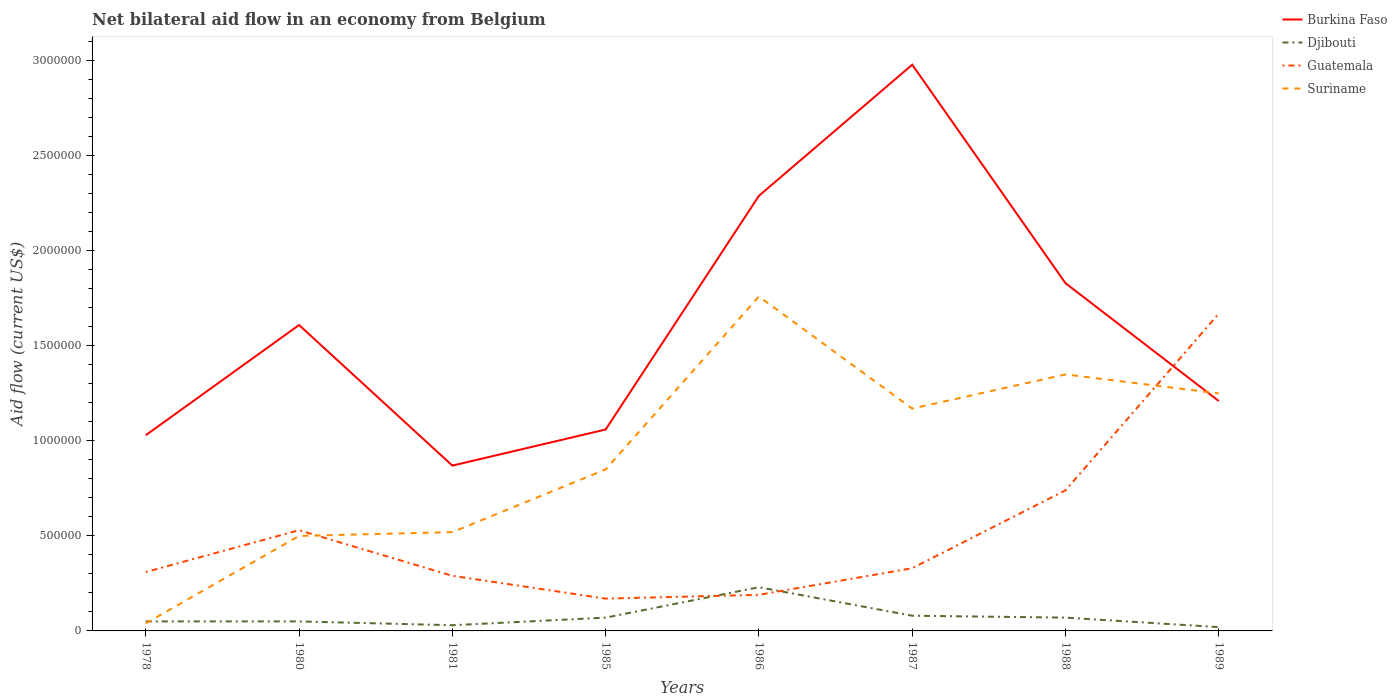Does the line corresponding to Burkina Faso intersect with the line corresponding to Djibouti?
Your response must be concise. No. Is the number of lines equal to the number of legend labels?
Make the answer very short. Yes. Across all years, what is the maximum net bilateral aid flow in Suriname?
Ensure brevity in your answer.  4.00e+04. What is the total net bilateral aid flow in Guatemala in the graph?
Give a very brief answer. -1.38e+06. What is the difference between the highest and the second highest net bilateral aid flow in Djibouti?
Offer a very short reply. 2.10e+05. What is the difference between the highest and the lowest net bilateral aid flow in Suriname?
Give a very brief answer. 4. Is the net bilateral aid flow in Burkina Faso strictly greater than the net bilateral aid flow in Djibouti over the years?
Your response must be concise. No. How many years are there in the graph?
Offer a very short reply. 8. Does the graph contain any zero values?
Give a very brief answer. No. Does the graph contain grids?
Provide a succinct answer. No. Where does the legend appear in the graph?
Keep it short and to the point. Top right. What is the title of the graph?
Your answer should be very brief. Net bilateral aid flow in an economy from Belgium. Does "Panama" appear as one of the legend labels in the graph?
Provide a succinct answer. No. What is the Aid flow (current US$) of Burkina Faso in 1978?
Offer a terse response. 1.03e+06. What is the Aid flow (current US$) of Djibouti in 1978?
Give a very brief answer. 5.00e+04. What is the Aid flow (current US$) in Guatemala in 1978?
Your response must be concise. 3.10e+05. What is the Aid flow (current US$) in Burkina Faso in 1980?
Keep it short and to the point. 1.61e+06. What is the Aid flow (current US$) of Guatemala in 1980?
Give a very brief answer. 5.30e+05. What is the Aid flow (current US$) of Suriname in 1980?
Make the answer very short. 5.00e+05. What is the Aid flow (current US$) in Burkina Faso in 1981?
Offer a terse response. 8.70e+05. What is the Aid flow (current US$) of Djibouti in 1981?
Ensure brevity in your answer.  3.00e+04. What is the Aid flow (current US$) in Guatemala in 1981?
Your response must be concise. 2.90e+05. What is the Aid flow (current US$) in Suriname in 1981?
Offer a terse response. 5.20e+05. What is the Aid flow (current US$) of Burkina Faso in 1985?
Ensure brevity in your answer.  1.06e+06. What is the Aid flow (current US$) of Suriname in 1985?
Your response must be concise. 8.50e+05. What is the Aid flow (current US$) in Burkina Faso in 1986?
Your answer should be very brief. 2.29e+06. What is the Aid flow (current US$) of Djibouti in 1986?
Your answer should be compact. 2.30e+05. What is the Aid flow (current US$) in Suriname in 1986?
Your answer should be very brief. 1.76e+06. What is the Aid flow (current US$) in Burkina Faso in 1987?
Your response must be concise. 2.98e+06. What is the Aid flow (current US$) in Suriname in 1987?
Ensure brevity in your answer.  1.17e+06. What is the Aid flow (current US$) of Burkina Faso in 1988?
Offer a terse response. 1.83e+06. What is the Aid flow (current US$) of Djibouti in 1988?
Your answer should be compact. 7.00e+04. What is the Aid flow (current US$) in Guatemala in 1988?
Ensure brevity in your answer.  7.40e+05. What is the Aid flow (current US$) of Suriname in 1988?
Your answer should be compact. 1.35e+06. What is the Aid flow (current US$) of Burkina Faso in 1989?
Your answer should be very brief. 1.21e+06. What is the Aid flow (current US$) of Djibouti in 1989?
Ensure brevity in your answer.  2.00e+04. What is the Aid flow (current US$) of Guatemala in 1989?
Your answer should be very brief. 1.67e+06. What is the Aid flow (current US$) of Suriname in 1989?
Provide a succinct answer. 1.25e+06. Across all years, what is the maximum Aid flow (current US$) of Burkina Faso?
Your answer should be compact. 2.98e+06. Across all years, what is the maximum Aid flow (current US$) of Guatemala?
Keep it short and to the point. 1.67e+06. Across all years, what is the maximum Aid flow (current US$) in Suriname?
Offer a terse response. 1.76e+06. Across all years, what is the minimum Aid flow (current US$) of Burkina Faso?
Offer a terse response. 8.70e+05. Across all years, what is the minimum Aid flow (current US$) in Guatemala?
Ensure brevity in your answer.  1.70e+05. Across all years, what is the minimum Aid flow (current US$) in Suriname?
Your answer should be very brief. 4.00e+04. What is the total Aid flow (current US$) in Burkina Faso in the graph?
Offer a terse response. 1.29e+07. What is the total Aid flow (current US$) in Guatemala in the graph?
Provide a succinct answer. 4.23e+06. What is the total Aid flow (current US$) in Suriname in the graph?
Offer a very short reply. 7.44e+06. What is the difference between the Aid flow (current US$) in Burkina Faso in 1978 and that in 1980?
Give a very brief answer. -5.80e+05. What is the difference between the Aid flow (current US$) of Guatemala in 1978 and that in 1980?
Provide a short and direct response. -2.20e+05. What is the difference between the Aid flow (current US$) of Suriname in 1978 and that in 1980?
Give a very brief answer. -4.60e+05. What is the difference between the Aid flow (current US$) of Burkina Faso in 1978 and that in 1981?
Give a very brief answer. 1.60e+05. What is the difference between the Aid flow (current US$) of Guatemala in 1978 and that in 1981?
Provide a succinct answer. 2.00e+04. What is the difference between the Aid flow (current US$) of Suriname in 1978 and that in 1981?
Your answer should be compact. -4.80e+05. What is the difference between the Aid flow (current US$) of Burkina Faso in 1978 and that in 1985?
Your answer should be compact. -3.00e+04. What is the difference between the Aid flow (current US$) in Guatemala in 1978 and that in 1985?
Offer a very short reply. 1.40e+05. What is the difference between the Aid flow (current US$) in Suriname in 1978 and that in 1985?
Your answer should be very brief. -8.10e+05. What is the difference between the Aid flow (current US$) in Burkina Faso in 1978 and that in 1986?
Keep it short and to the point. -1.26e+06. What is the difference between the Aid flow (current US$) in Djibouti in 1978 and that in 1986?
Provide a succinct answer. -1.80e+05. What is the difference between the Aid flow (current US$) in Guatemala in 1978 and that in 1986?
Offer a terse response. 1.20e+05. What is the difference between the Aid flow (current US$) of Suriname in 1978 and that in 1986?
Your answer should be very brief. -1.72e+06. What is the difference between the Aid flow (current US$) in Burkina Faso in 1978 and that in 1987?
Provide a succinct answer. -1.95e+06. What is the difference between the Aid flow (current US$) of Suriname in 1978 and that in 1987?
Your answer should be very brief. -1.13e+06. What is the difference between the Aid flow (current US$) of Burkina Faso in 1978 and that in 1988?
Offer a terse response. -8.00e+05. What is the difference between the Aid flow (current US$) of Djibouti in 1978 and that in 1988?
Make the answer very short. -2.00e+04. What is the difference between the Aid flow (current US$) in Guatemala in 1978 and that in 1988?
Keep it short and to the point. -4.30e+05. What is the difference between the Aid flow (current US$) of Suriname in 1978 and that in 1988?
Provide a short and direct response. -1.31e+06. What is the difference between the Aid flow (current US$) of Burkina Faso in 1978 and that in 1989?
Your response must be concise. -1.80e+05. What is the difference between the Aid flow (current US$) of Djibouti in 1978 and that in 1989?
Provide a succinct answer. 3.00e+04. What is the difference between the Aid flow (current US$) in Guatemala in 1978 and that in 1989?
Make the answer very short. -1.36e+06. What is the difference between the Aid flow (current US$) in Suriname in 1978 and that in 1989?
Keep it short and to the point. -1.21e+06. What is the difference between the Aid flow (current US$) of Burkina Faso in 1980 and that in 1981?
Make the answer very short. 7.40e+05. What is the difference between the Aid flow (current US$) of Djibouti in 1980 and that in 1981?
Ensure brevity in your answer.  2.00e+04. What is the difference between the Aid flow (current US$) of Suriname in 1980 and that in 1981?
Keep it short and to the point. -2.00e+04. What is the difference between the Aid flow (current US$) in Burkina Faso in 1980 and that in 1985?
Your response must be concise. 5.50e+05. What is the difference between the Aid flow (current US$) in Guatemala in 1980 and that in 1985?
Your answer should be very brief. 3.60e+05. What is the difference between the Aid flow (current US$) in Suriname in 1980 and that in 1985?
Provide a succinct answer. -3.50e+05. What is the difference between the Aid flow (current US$) of Burkina Faso in 1980 and that in 1986?
Give a very brief answer. -6.80e+05. What is the difference between the Aid flow (current US$) in Guatemala in 1980 and that in 1986?
Ensure brevity in your answer.  3.40e+05. What is the difference between the Aid flow (current US$) of Suriname in 1980 and that in 1986?
Your answer should be compact. -1.26e+06. What is the difference between the Aid flow (current US$) in Burkina Faso in 1980 and that in 1987?
Your response must be concise. -1.37e+06. What is the difference between the Aid flow (current US$) of Djibouti in 1980 and that in 1987?
Give a very brief answer. -3.00e+04. What is the difference between the Aid flow (current US$) of Suriname in 1980 and that in 1987?
Provide a succinct answer. -6.70e+05. What is the difference between the Aid flow (current US$) in Djibouti in 1980 and that in 1988?
Provide a short and direct response. -2.00e+04. What is the difference between the Aid flow (current US$) of Guatemala in 1980 and that in 1988?
Provide a succinct answer. -2.10e+05. What is the difference between the Aid flow (current US$) of Suriname in 1980 and that in 1988?
Your answer should be compact. -8.50e+05. What is the difference between the Aid flow (current US$) of Burkina Faso in 1980 and that in 1989?
Ensure brevity in your answer.  4.00e+05. What is the difference between the Aid flow (current US$) in Djibouti in 1980 and that in 1989?
Provide a succinct answer. 3.00e+04. What is the difference between the Aid flow (current US$) in Guatemala in 1980 and that in 1989?
Make the answer very short. -1.14e+06. What is the difference between the Aid flow (current US$) in Suriname in 1980 and that in 1989?
Your answer should be compact. -7.50e+05. What is the difference between the Aid flow (current US$) of Guatemala in 1981 and that in 1985?
Ensure brevity in your answer.  1.20e+05. What is the difference between the Aid flow (current US$) in Suriname in 1981 and that in 1985?
Offer a terse response. -3.30e+05. What is the difference between the Aid flow (current US$) in Burkina Faso in 1981 and that in 1986?
Ensure brevity in your answer.  -1.42e+06. What is the difference between the Aid flow (current US$) in Djibouti in 1981 and that in 1986?
Offer a very short reply. -2.00e+05. What is the difference between the Aid flow (current US$) in Guatemala in 1981 and that in 1986?
Your answer should be compact. 1.00e+05. What is the difference between the Aid flow (current US$) of Suriname in 1981 and that in 1986?
Your answer should be very brief. -1.24e+06. What is the difference between the Aid flow (current US$) in Burkina Faso in 1981 and that in 1987?
Offer a very short reply. -2.11e+06. What is the difference between the Aid flow (current US$) in Guatemala in 1981 and that in 1987?
Ensure brevity in your answer.  -4.00e+04. What is the difference between the Aid flow (current US$) of Suriname in 1981 and that in 1987?
Make the answer very short. -6.50e+05. What is the difference between the Aid flow (current US$) in Burkina Faso in 1981 and that in 1988?
Provide a succinct answer. -9.60e+05. What is the difference between the Aid flow (current US$) in Guatemala in 1981 and that in 1988?
Make the answer very short. -4.50e+05. What is the difference between the Aid flow (current US$) of Suriname in 1981 and that in 1988?
Ensure brevity in your answer.  -8.30e+05. What is the difference between the Aid flow (current US$) of Djibouti in 1981 and that in 1989?
Provide a succinct answer. 10000. What is the difference between the Aid flow (current US$) of Guatemala in 1981 and that in 1989?
Offer a terse response. -1.38e+06. What is the difference between the Aid flow (current US$) in Suriname in 1981 and that in 1989?
Your response must be concise. -7.30e+05. What is the difference between the Aid flow (current US$) in Burkina Faso in 1985 and that in 1986?
Make the answer very short. -1.23e+06. What is the difference between the Aid flow (current US$) of Suriname in 1985 and that in 1986?
Keep it short and to the point. -9.10e+05. What is the difference between the Aid flow (current US$) in Burkina Faso in 1985 and that in 1987?
Provide a succinct answer. -1.92e+06. What is the difference between the Aid flow (current US$) in Guatemala in 1985 and that in 1987?
Your answer should be compact. -1.60e+05. What is the difference between the Aid flow (current US$) in Suriname in 1985 and that in 1987?
Offer a very short reply. -3.20e+05. What is the difference between the Aid flow (current US$) in Burkina Faso in 1985 and that in 1988?
Keep it short and to the point. -7.70e+05. What is the difference between the Aid flow (current US$) of Guatemala in 1985 and that in 1988?
Ensure brevity in your answer.  -5.70e+05. What is the difference between the Aid flow (current US$) in Suriname in 1985 and that in 1988?
Ensure brevity in your answer.  -5.00e+05. What is the difference between the Aid flow (current US$) in Guatemala in 1985 and that in 1989?
Offer a very short reply. -1.50e+06. What is the difference between the Aid flow (current US$) in Suriname in 1985 and that in 1989?
Your response must be concise. -4.00e+05. What is the difference between the Aid flow (current US$) of Burkina Faso in 1986 and that in 1987?
Make the answer very short. -6.90e+05. What is the difference between the Aid flow (current US$) in Suriname in 1986 and that in 1987?
Provide a succinct answer. 5.90e+05. What is the difference between the Aid flow (current US$) of Burkina Faso in 1986 and that in 1988?
Offer a very short reply. 4.60e+05. What is the difference between the Aid flow (current US$) of Guatemala in 1986 and that in 1988?
Your answer should be compact. -5.50e+05. What is the difference between the Aid flow (current US$) of Suriname in 1986 and that in 1988?
Offer a terse response. 4.10e+05. What is the difference between the Aid flow (current US$) of Burkina Faso in 1986 and that in 1989?
Your answer should be very brief. 1.08e+06. What is the difference between the Aid flow (current US$) in Djibouti in 1986 and that in 1989?
Your response must be concise. 2.10e+05. What is the difference between the Aid flow (current US$) in Guatemala in 1986 and that in 1989?
Your response must be concise. -1.48e+06. What is the difference between the Aid flow (current US$) of Suriname in 1986 and that in 1989?
Your response must be concise. 5.10e+05. What is the difference between the Aid flow (current US$) of Burkina Faso in 1987 and that in 1988?
Offer a terse response. 1.15e+06. What is the difference between the Aid flow (current US$) in Guatemala in 1987 and that in 1988?
Offer a terse response. -4.10e+05. What is the difference between the Aid flow (current US$) of Burkina Faso in 1987 and that in 1989?
Your answer should be compact. 1.77e+06. What is the difference between the Aid flow (current US$) of Guatemala in 1987 and that in 1989?
Keep it short and to the point. -1.34e+06. What is the difference between the Aid flow (current US$) in Burkina Faso in 1988 and that in 1989?
Your response must be concise. 6.20e+05. What is the difference between the Aid flow (current US$) in Djibouti in 1988 and that in 1989?
Offer a very short reply. 5.00e+04. What is the difference between the Aid flow (current US$) in Guatemala in 1988 and that in 1989?
Your answer should be compact. -9.30e+05. What is the difference between the Aid flow (current US$) in Suriname in 1988 and that in 1989?
Offer a very short reply. 1.00e+05. What is the difference between the Aid flow (current US$) in Burkina Faso in 1978 and the Aid flow (current US$) in Djibouti in 1980?
Keep it short and to the point. 9.80e+05. What is the difference between the Aid flow (current US$) of Burkina Faso in 1978 and the Aid flow (current US$) of Suriname in 1980?
Ensure brevity in your answer.  5.30e+05. What is the difference between the Aid flow (current US$) in Djibouti in 1978 and the Aid flow (current US$) in Guatemala in 1980?
Your answer should be very brief. -4.80e+05. What is the difference between the Aid flow (current US$) in Djibouti in 1978 and the Aid flow (current US$) in Suriname in 1980?
Provide a succinct answer. -4.50e+05. What is the difference between the Aid flow (current US$) of Guatemala in 1978 and the Aid flow (current US$) of Suriname in 1980?
Provide a short and direct response. -1.90e+05. What is the difference between the Aid flow (current US$) in Burkina Faso in 1978 and the Aid flow (current US$) in Djibouti in 1981?
Offer a terse response. 1.00e+06. What is the difference between the Aid flow (current US$) of Burkina Faso in 1978 and the Aid flow (current US$) of Guatemala in 1981?
Give a very brief answer. 7.40e+05. What is the difference between the Aid flow (current US$) of Burkina Faso in 1978 and the Aid flow (current US$) of Suriname in 1981?
Offer a terse response. 5.10e+05. What is the difference between the Aid flow (current US$) in Djibouti in 1978 and the Aid flow (current US$) in Suriname in 1981?
Offer a terse response. -4.70e+05. What is the difference between the Aid flow (current US$) of Burkina Faso in 1978 and the Aid flow (current US$) of Djibouti in 1985?
Ensure brevity in your answer.  9.60e+05. What is the difference between the Aid flow (current US$) in Burkina Faso in 1978 and the Aid flow (current US$) in Guatemala in 1985?
Make the answer very short. 8.60e+05. What is the difference between the Aid flow (current US$) in Djibouti in 1978 and the Aid flow (current US$) in Guatemala in 1985?
Give a very brief answer. -1.20e+05. What is the difference between the Aid flow (current US$) of Djibouti in 1978 and the Aid flow (current US$) of Suriname in 1985?
Keep it short and to the point. -8.00e+05. What is the difference between the Aid flow (current US$) in Guatemala in 1978 and the Aid flow (current US$) in Suriname in 1985?
Your answer should be compact. -5.40e+05. What is the difference between the Aid flow (current US$) of Burkina Faso in 1978 and the Aid flow (current US$) of Djibouti in 1986?
Keep it short and to the point. 8.00e+05. What is the difference between the Aid flow (current US$) of Burkina Faso in 1978 and the Aid flow (current US$) of Guatemala in 1986?
Your answer should be compact. 8.40e+05. What is the difference between the Aid flow (current US$) of Burkina Faso in 1978 and the Aid flow (current US$) of Suriname in 1986?
Give a very brief answer. -7.30e+05. What is the difference between the Aid flow (current US$) of Djibouti in 1978 and the Aid flow (current US$) of Suriname in 1986?
Make the answer very short. -1.71e+06. What is the difference between the Aid flow (current US$) in Guatemala in 1978 and the Aid flow (current US$) in Suriname in 1986?
Keep it short and to the point. -1.45e+06. What is the difference between the Aid flow (current US$) in Burkina Faso in 1978 and the Aid flow (current US$) in Djibouti in 1987?
Offer a very short reply. 9.50e+05. What is the difference between the Aid flow (current US$) in Burkina Faso in 1978 and the Aid flow (current US$) in Suriname in 1987?
Your answer should be very brief. -1.40e+05. What is the difference between the Aid flow (current US$) in Djibouti in 1978 and the Aid flow (current US$) in Guatemala in 1987?
Your response must be concise. -2.80e+05. What is the difference between the Aid flow (current US$) in Djibouti in 1978 and the Aid flow (current US$) in Suriname in 1987?
Provide a short and direct response. -1.12e+06. What is the difference between the Aid flow (current US$) in Guatemala in 1978 and the Aid flow (current US$) in Suriname in 1987?
Keep it short and to the point. -8.60e+05. What is the difference between the Aid flow (current US$) in Burkina Faso in 1978 and the Aid flow (current US$) in Djibouti in 1988?
Provide a short and direct response. 9.60e+05. What is the difference between the Aid flow (current US$) of Burkina Faso in 1978 and the Aid flow (current US$) of Suriname in 1988?
Offer a terse response. -3.20e+05. What is the difference between the Aid flow (current US$) of Djibouti in 1978 and the Aid flow (current US$) of Guatemala in 1988?
Ensure brevity in your answer.  -6.90e+05. What is the difference between the Aid flow (current US$) of Djibouti in 1978 and the Aid flow (current US$) of Suriname in 1988?
Offer a terse response. -1.30e+06. What is the difference between the Aid flow (current US$) of Guatemala in 1978 and the Aid flow (current US$) of Suriname in 1988?
Your response must be concise. -1.04e+06. What is the difference between the Aid flow (current US$) in Burkina Faso in 1978 and the Aid flow (current US$) in Djibouti in 1989?
Provide a succinct answer. 1.01e+06. What is the difference between the Aid flow (current US$) of Burkina Faso in 1978 and the Aid flow (current US$) of Guatemala in 1989?
Keep it short and to the point. -6.40e+05. What is the difference between the Aid flow (current US$) of Djibouti in 1978 and the Aid flow (current US$) of Guatemala in 1989?
Keep it short and to the point. -1.62e+06. What is the difference between the Aid flow (current US$) of Djibouti in 1978 and the Aid flow (current US$) of Suriname in 1989?
Your answer should be very brief. -1.20e+06. What is the difference between the Aid flow (current US$) in Guatemala in 1978 and the Aid flow (current US$) in Suriname in 1989?
Provide a succinct answer. -9.40e+05. What is the difference between the Aid flow (current US$) of Burkina Faso in 1980 and the Aid flow (current US$) of Djibouti in 1981?
Offer a terse response. 1.58e+06. What is the difference between the Aid flow (current US$) in Burkina Faso in 1980 and the Aid flow (current US$) in Guatemala in 1981?
Offer a terse response. 1.32e+06. What is the difference between the Aid flow (current US$) in Burkina Faso in 1980 and the Aid flow (current US$) in Suriname in 1981?
Offer a terse response. 1.09e+06. What is the difference between the Aid flow (current US$) of Djibouti in 1980 and the Aid flow (current US$) of Suriname in 1981?
Your answer should be compact. -4.70e+05. What is the difference between the Aid flow (current US$) of Burkina Faso in 1980 and the Aid flow (current US$) of Djibouti in 1985?
Make the answer very short. 1.54e+06. What is the difference between the Aid flow (current US$) in Burkina Faso in 1980 and the Aid flow (current US$) in Guatemala in 1985?
Your answer should be compact. 1.44e+06. What is the difference between the Aid flow (current US$) in Burkina Faso in 1980 and the Aid flow (current US$) in Suriname in 1985?
Your response must be concise. 7.60e+05. What is the difference between the Aid flow (current US$) in Djibouti in 1980 and the Aid flow (current US$) in Guatemala in 1985?
Give a very brief answer. -1.20e+05. What is the difference between the Aid flow (current US$) in Djibouti in 1980 and the Aid flow (current US$) in Suriname in 1985?
Give a very brief answer. -8.00e+05. What is the difference between the Aid flow (current US$) in Guatemala in 1980 and the Aid flow (current US$) in Suriname in 1985?
Provide a short and direct response. -3.20e+05. What is the difference between the Aid flow (current US$) of Burkina Faso in 1980 and the Aid flow (current US$) of Djibouti in 1986?
Your answer should be very brief. 1.38e+06. What is the difference between the Aid flow (current US$) of Burkina Faso in 1980 and the Aid flow (current US$) of Guatemala in 1986?
Your answer should be compact. 1.42e+06. What is the difference between the Aid flow (current US$) in Djibouti in 1980 and the Aid flow (current US$) in Suriname in 1986?
Make the answer very short. -1.71e+06. What is the difference between the Aid flow (current US$) of Guatemala in 1980 and the Aid flow (current US$) of Suriname in 1986?
Your answer should be very brief. -1.23e+06. What is the difference between the Aid flow (current US$) of Burkina Faso in 1980 and the Aid flow (current US$) of Djibouti in 1987?
Make the answer very short. 1.53e+06. What is the difference between the Aid flow (current US$) in Burkina Faso in 1980 and the Aid flow (current US$) in Guatemala in 1987?
Your response must be concise. 1.28e+06. What is the difference between the Aid flow (current US$) in Burkina Faso in 1980 and the Aid flow (current US$) in Suriname in 1987?
Offer a terse response. 4.40e+05. What is the difference between the Aid flow (current US$) in Djibouti in 1980 and the Aid flow (current US$) in Guatemala in 1987?
Offer a very short reply. -2.80e+05. What is the difference between the Aid flow (current US$) in Djibouti in 1980 and the Aid flow (current US$) in Suriname in 1987?
Make the answer very short. -1.12e+06. What is the difference between the Aid flow (current US$) of Guatemala in 1980 and the Aid flow (current US$) of Suriname in 1987?
Keep it short and to the point. -6.40e+05. What is the difference between the Aid flow (current US$) in Burkina Faso in 1980 and the Aid flow (current US$) in Djibouti in 1988?
Keep it short and to the point. 1.54e+06. What is the difference between the Aid flow (current US$) of Burkina Faso in 1980 and the Aid flow (current US$) of Guatemala in 1988?
Offer a terse response. 8.70e+05. What is the difference between the Aid flow (current US$) in Burkina Faso in 1980 and the Aid flow (current US$) in Suriname in 1988?
Offer a terse response. 2.60e+05. What is the difference between the Aid flow (current US$) of Djibouti in 1980 and the Aid flow (current US$) of Guatemala in 1988?
Your response must be concise. -6.90e+05. What is the difference between the Aid flow (current US$) in Djibouti in 1980 and the Aid flow (current US$) in Suriname in 1988?
Your response must be concise. -1.30e+06. What is the difference between the Aid flow (current US$) of Guatemala in 1980 and the Aid flow (current US$) of Suriname in 1988?
Make the answer very short. -8.20e+05. What is the difference between the Aid flow (current US$) of Burkina Faso in 1980 and the Aid flow (current US$) of Djibouti in 1989?
Your answer should be compact. 1.59e+06. What is the difference between the Aid flow (current US$) of Burkina Faso in 1980 and the Aid flow (current US$) of Suriname in 1989?
Provide a short and direct response. 3.60e+05. What is the difference between the Aid flow (current US$) in Djibouti in 1980 and the Aid flow (current US$) in Guatemala in 1989?
Offer a very short reply. -1.62e+06. What is the difference between the Aid flow (current US$) in Djibouti in 1980 and the Aid flow (current US$) in Suriname in 1989?
Offer a terse response. -1.20e+06. What is the difference between the Aid flow (current US$) in Guatemala in 1980 and the Aid flow (current US$) in Suriname in 1989?
Your answer should be compact. -7.20e+05. What is the difference between the Aid flow (current US$) of Burkina Faso in 1981 and the Aid flow (current US$) of Djibouti in 1985?
Give a very brief answer. 8.00e+05. What is the difference between the Aid flow (current US$) of Burkina Faso in 1981 and the Aid flow (current US$) of Guatemala in 1985?
Make the answer very short. 7.00e+05. What is the difference between the Aid flow (current US$) in Burkina Faso in 1981 and the Aid flow (current US$) in Suriname in 1985?
Offer a very short reply. 2.00e+04. What is the difference between the Aid flow (current US$) in Djibouti in 1981 and the Aid flow (current US$) in Suriname in 1985?
Give a very brief answer. -8.20e+05. What is the difference between the Aid flow (current US$) in Guatemala in 1981 and the Aid flow (current US$) in Suriname in 1985?
Ensure brevity in your answer.  -5.60e+05. What is the difference between the Aid flow (current US$) in Burkina Faso in 1981 and the Aid flow (current US$) in Djibouti in 1986?
Ensure brevity in your answer.  6.40e+05. What is the difference between the Aid flow (current US$) in Burkina Faso in 1981 and the Aid flow (current US$) in Guatemala in 1986?
Provide a succinct answer. 6.80e+05. What is the difference between the Aid flow (current US$) in Burkina Faso in 1981 and the Aid flow (current US$) in Suriname in 1986?
Offer a terse response. -8.90e+05. What is the difference between the Aid flow (current US$) of Djibouti in 1981 and the Aid flow (current US$) of Guatemala in 1986?
Give a very brief answer. -1.60e+05. What is the difference between the Aid flow (current US$) in Djibouti in 1981 and the Aid flow (current US$) in Suriname in 1986?
Offer a very short reply. -1.73e+06. What is the difference between the Aid flow (current US$) in Guatemala in 1981 and the Aid flow (current US$) in Suriname in 1986?
Make the answer very short. -1.47e+06. What is the difference between the Aid flow (current US$) of Burkina Faso in 1981 and the Aid flow (current US$) of Djibouti in 1987?
Your answer should be very brief. 7.90e+05. What is the difference between the Aid flow (current US$) in Burkina Faso in 1981 and the Aid flow (current US$) in Guatemala in 1987?
Provide a short and direct response. 5.40e+05. What is the difference between the Aid flow (current US$) of Djibouti in 1981 and the Aid flow (current US$) of Suriname in 1987?
Offer a very short reply. -1.14e+06. What is the difference between the Aid flow (current US$) in Guatemala in 1981 and the Aid flow (current US$) in Suriname in 1987?
Your answer should be very brief. -8.80e+05. What is the difference between the Aid flow (current US$) in Burkina Faso in 1981 and the Aid flow (current US$) in Suriname in 1988?
Provide a short and direct response. -4.80e+05. What is the difference between the Aid flow (current US$) of Djibouti in 1981 and the Aid flow (current US$) of Guatemala in 1988?
Offer a terse response. -7.10e+05. What is the difference between the Aid flow (current US$) of Djibouti in 1981 and the Aid flow (current US$) of Suriname in 1988?
Your answer should be very brief. -1.32e+06. What is the difference between the Aid flow (current US$) in Guatemala in 1981 and the Aid flow (current US$) in Suriname in 1988?
Offer a very short reply. -1.06e+06. What is the difference between the Aid flow (current US$) of Burkina Faso in 1981 and the Aid flow (current US$) of Djibouti in 1989?
Your response must be concise. 8.50e+05. What is the difference between the Aid flow (current US$) of Burkina Faso in 1981 and the Aid flow (current US$) of Guatemala in 1989?
Provide a succinct answer. -8.00e+05. What is the difference between the Aid flow (current US$) in Burkina Faso in 1981 and the Aid flow (current US$) in Suriname in 1989?
Ensure brevity in your answer.  -3.80e+05. What is the difference between the Aid flow (current US$) in Djibouti in 1981 and the Aid flow (current US$) in Guatemala in 1989?
Give a very brief answer. -1.64e+06. What is the difference between the Aid flow (current US$) in Djibouti in 1981 and the Aid flow (current US$) in Suriname in 1989?
Offer a very short reply. -1.22e+06. What is the difference between the Aid flow (current US$) in Guatemala in 1981 and the Aid flow (current US$) in Suriname in 1989?
Ensure brevity in your answer.  -9.60e+05. What is the difference between the Aid flow (current US$) of Burkina Faso in 1985 and the Aid flow (current US$) of Djibouti in 1986?
Make the answer very short. 8.30e+05. What is the difference between the Aid flow (current US$) in Burkina Faso in 1985 and the Aid flow (current US$) in Guatemala in 1986?
Provide a succinct answer. 8.70e+05. What is the difference between the Aid flow (current US$) in Burkina Faso in 1985 and the Aid flow (current US$) in Suriname in 1986?
Offer a terse response. -7.00e+05. What is the difference between the Aid flow (current US$) in Djibouti in 1985 and the Aid flow (current US$) in Guatemala in 1986?
Give a very brief answer. -1.20e+05. What is the difference between the Aid flow (current US$) of Djibouti in 1985 and the Aid flow (current US$) of Suriname in 1986?
Your answer should be compact. -1.69e+06. What is the difference between the Aid flow (current US$) of Guatemala in 1985 and the Aid flow (current US$) of Suriname in 1986?
Provide a succinct answer. -1.59e+06. What is the difference between the Aid flow (current US$) in Burkina Faso in 1985 and the Aid flow (current US$) in Djibouti in 1987?
Your answer should be compact. 9.80e+05. What is the difference between the Aid flow (current US$) in Burkina Faso in 1985 and the Aid flow (current US$) in Guatemala in 1987?
Provide a succinct answer. 7.30e+05. What is the difference between the Aid flow (current US$) in Djibouti in 1985 and the Aid flow (current US$) in Suriname in 1987?
Offer a terse response. -1.10e+06. What is the difference between the Aid flow (current US$) of Guatemala in 1985 and the Aid flow (current US$) of Suriname in 1987?
Make the answer very short. -1.00e+06. What is the difference between the Aid flow (current US$) of Burkina Faso in 1985 and the Aid flow (current US$) of Djibouti in 1988?
Your answer should be compact. 9.90e+05. What is the difference between the Aid flow (current US$) in Burkina Faso in 1985 and the Aid flow (current US$) in Guatemala in 1988?
Make the answer very short. 3.20e+05. What is the difference between the Aid flow (current US$) in Burkina Faso in 1985 and the Aid flow (current US$) in Suriname in 1988?
Make the answer very short. -2.90e+05. What is the difference between the Aid flow (current US$) in Djibouti in 1985 and the Aid flow (current US$) in Guatemala in 1988?
Give a very brief answer. -6.70e+05. What is the difference between the Aid flow (current US$) of Djibouti in 1985 and the Aid flow (current US$) of Suriname in 1988?
Your response must be concise. -1.28e+06. What is the difference between the Aid flow (current US$) of Guatemala in 1985 and the Aid flow (current US$) of Suriname in 1988?
Give a very brief answer. -1.18e+06. What is the difference between the Aid flow (current US$) of Burkina Faso in 1985 and the Aid flow (current US$) of Djibouti in 1989?
Keep it short and to the point. 1.04e+06. What is the difference between the Aid flow (current US$) in Burkina Faso in 1985 and the Aid flow (current US$) in Guatemala in 1989?
Your response must be concise. -6.10e+05. What is the difference between the Aid flow (current US$) in Burkina Faso in 1985 and the Aid flow (current US$) in Suriname in 1989?
Your answer should be very brief. -1.90e+05. What is the difference between the Aid flow (current US$) of Djibouti in 1985 and the Aid flow (current US$) of Guatemala in 1989?
Keep it short and to the point. -1.60e+06. What is the difference between the Aid flow (current US$) in Djibouti in 1985 and the Aid flow (current US$) in Suriname in 1989?
Your answer should be very brief. -1.18e+06. What is the difference between the Aid flow (current US$) of Guatemala in 1985 and the Aid flow (current US$) of Suriname in 1989?
Give a very brief answer. -1.08e+06. What is the difference between the Aid flow (current US$) of Burkina Faso in 1986 and the Aid flow (current US$) of Djibouti in 1987?
Offer a terse response. 2.21e+06. What is the difference between the Aid flow (current US$) in Burkina Faso in 1986 and the Aid flow (current US$) in Guatemala in 1987?
Your answer should be very brief. 1.96e+06. What is the difference between the Aid flow (current US$) in Burkina Faso in 1986 and the Aid flow (current US$) in Suriname in 1987?
Provide a succinct answer. 1.12e+06. What is the difference between the Aid flow (current US$) of Djibouti in 1986 and the Aid flow (current US$) of Guatemala in 1987?
Provide a short and direct response. -1.00e+05. What is the difference between the Aid flow (current US$) of Djibouti in 1986 and the Aid flow (current US$) of Suriname in 1987?
Make the answer very short. -9.40e+05. What is the difference between the Aid flow (current US$) of Guatemala in 1986 and the Aid flow (current US$) of Suriname in 1987?
Provide a succinct answer. -9.80e+05. What is the difference between the Aid flow (current US$) of Burkina Faso in 1986 and the Aid flow (current US$) of Djibouti in 1988?
Provide a succinct answer. 2.22e+06. What is the difference between the Aid flow (current US$) in Burkina Faso in 1986 and the Aid flow (current US$) in Guatemala in 1988?
Make the answer very short. 1.55e+06. What is the difference between the Aid flow (current US$) of Burkina Faso in 1986 and the Aid flow (current US$) of Suriname in 1988?
Provide a succinct answer. 9.40e+05. What is the difference between the Aid flow (current US$) of Djibouti in 1986 and the Aid flow (current US$) of Guatemala in 1988?
Offer a very short reply. -5.10e+05. What is the difference between the Aid flow (current US$) of Djibouti in 1986 and the Aid flow (current US$) of Suriname in 1988?
Ensure brevity in your answer.  -1.12e+06. What is the difference between the Aid flow (current US$) of Guatemala in 1986 and the Aid flow (current US$) of Suriname in 1988?
Your answer should be very brief. -1.16e+06. What is the difference between the Aid flow (current US$) in Burkina Faso in 1986 and the Aid flow (current US$) in Djibouti in 1989?
Give a very brief answer. 2.27e+06. What is the difference between the Aid flow (current US$) in Burkina Faso in 1986 and the Aid flow (current US$) in Guatemala in 1989?
Keep it short and to the point. 6.20e+05. What is the difference between the Aid flow (current US$) in Burkina Faso in 1986 and the Aid flow (current US$) in Suriname in 1989?
Make the answer very short. 1.04e+06. What is the difference between the Aid flow (current US$) of Djibouti in 1986 and the Aid flow (current US$) of Guatemala in 1989?
Ensure brevity in your answer.  -1.44e+06. What is the difference between the Aid flow (current US$) in Djibouti in 1986 and the Aid flow (current US$) in Suriname in 1989?
Your response must be concise. -1.02e+06. What is the difference between the Aid flow (current US$) of Guatemala in 1986 and the Aid flow (current US$) of Suriname in 1989?
Your answer should be compact. -1.06e+06. What is the difference between the Aid flow (current US$) of Burkina Faso in 1987 and the Aid flow (current US$) of Djibouti in 1988?
Offer a terse response. 2.91e+06. What is the difference between the Aid flow (current US$) in Burkina Faso in 1987 and the Aid flow (current US$) in Guatemala in 1988?
Make the answer very short. 2.24e+06. What is the difference between the Aid flow (current US$) in Burkina Faso in 1987 and the Aid flow (current US$) in Suriname in 1988?
Provide a succinct answer. 1.63e+06. What is the difference between the Aid flow (current US$) in Djibouti in 1987 and the Aid flow (current US$) in Guatemala in 1988?
Provide a succinct answer. -6.60e+05. What is the difference between the Aid flow (current US$) in Djibouti in 1987 and the Aid flow (current US$) in Suriname in 1988?
Provide a succinct answer. -1.27e+06. What is the difference between the Aid flow (current US$) in Guatemala in 1987 and the Aid flow (current US$) in Suriname in 1988?
Your answer should be compact. -1.02e+06. What is the difference between the Aid flow (current US$) of Burkina Faso in 1987 and the Aid flow (current US$) of Djibouti in 1989?
Give a very brief answer. 2.96e+06. What is the difference between the Aid flow (current US$) of Burkina Faso in 1987 and the Aid flow (current US$) of Guatemala in 1989?
Offer a terse response. 1.31e+06. What is the difference between the Aid flow (current US$) of Burkina Faso in 1987 and the Aid flow (current US$) of Suriname in 1989?
Give a very brief answer. 1.73e+06. What is the difference between the Aid flow (current US$) in Djibouti in 1987 and the Aid flow (current US$) in Guatemala in 1989?
Your response must be concise. -1.59e+06. What is the difference between the Aid flow (current US$) of Djibouti in 1987 and the Aid flow (current US$) of Suriname in 1989?
Make the answer very short. -1.17e+06. What is the difference between the Aid flow (current US$) in Guatemala in 1987 and the Aid flow (current US$) in Suriname in 1989?
Offer a terse response. -9.20e+05. What is the difference between the Aid flow (current US$) of Burkina Faso in 1988 and the Aid flow (current US$) of Djibouti in 1989?
Your answer should be very brief. 1.81e+06. What is the difference between the Aid flow (current US$) of Burkina Faso in 1988 and the Aid flow (current US$) of Suriname in 1989?
Ensure brevity in your answer.  5.80e+05. What is the difference between the Aid flow (current US$) of Djibouti in 1988 and the Aid flow (current US$) of Guatemala in 1989?
Your answer should be very brief. -1.60e+06. What is the difference between the Aid flow (current US$) in Djibouti in 1988 and the Aid flow (current US$) in Suriname in 1989?
Your answer should be very brief. -1.18e+06. What is the difference between the Aid flow (current US$) of Guatemala in 1988 and the Aid flow (current US$) of Suriname in 1989?
Give a very brief answer. -5.10e+05. What is the average Aid flow (current US$) in Burkina Faso per year?
Offer a terse response. 1.61e+06. What is the average Aid flow (current US$) in Djibouti per year?
Your answer should be compact. 7.50e+04. What is the average Aid flow (current US$) of Guatemala per year?
Provide a short and direct response. 5.29e+05. What is the average Aid flow (current US$) in Suriname per year?
Give a very brief answer. 9.30e+05. In the year 1978, what is the difference between the Aid flow (current US$) in Burkina Faso and Aid flow (current US$) in Djibouti?
Ensure brevity in your answer.  9.80e+05. In the year 1978, what is the difference between the Aid flow (current US$) of Burkina Faso and Aid flow (current US$) of Guatemala?
Offer a very short reply. 7.20e+05. In the year 1978, what is the difference between the Aid flow (current US$) in Burkina Faso and Aid flow (current US$) in Suriname?
Your answer should be compact. 9.90e+05. In the year 1978, what is the difference between the Aid flow (current US$) of Guatemala and Aid flow (current US$) of Suriname?
Give a very brief answer. 2.70e+05. In the year 1980, what is the difference between the Aid flow (current US$) of Burkina Faso and Aid flow (current US$) of Djibouti?
Keep it short and to the point. 1.56e+06. In the year 1980, what is the difference between the Aid flow (current US$) in Burkina Faso and Aid flow (current US$) in Guatemala?
Provide a short and direct response. 1.08e+06. In the year 1980, what is the difference between the Aid flow (current US$) in Burkina Faso and Aid flow (current US$) in Suriname?
Your answer should be very brief. 1.11e+06. In the year 1980, what is the difference between the Aid flow (current US$) of Djibouti and Aid flow (current US$) of Guatemala?
Give a very brief answer. -4.80e+05. In the year 1980, what is the difference between the Aid flow (current US$) in Djibouti and Aid flow (current US$) in Suriname?
Keep it short and to the point. -4.50e+05. In the year 1980, what is the difference between the Aid flow (current US$) in Guatemala and Aid flow (current US$) in Suriname?
Give a very brief answer. 3.00e+04. In the year 1981, what is the difference between the Aid flow (current US$) of Burkina Faso and Aid flow (current US$) of Djibouti?
Offer a very short reply. 8.40e+05. In the year 1981, what is the difference between the Aid flow (current US$) of Burkina Faso and Aid flow (current US$) of Guatemala?
Provide a short and direct response. 5.80e+05. In the year 1981, what is the difference between the Aid flow (current US$) of Djibouti and Aid flow (current US$) of Suriname?
Give a very brief answer. -4.90e+05. In the year 1981, what is the difference between the Aid flow (current US$) in Guatemala and Aid flow (current US$) in Suriname?
Keep it short and to the point. -2.30e+05. In the year 1985, what is the difference between the Aid flow (current US$) in Burkina Faso and Aid flow (current US$) in Djibouti?
Offer a terse response. 9.90e+05. In the year 1985, what is the difference between the Aid flow (current US$) of Burkina Faso and Aid flow (current US$) of Guatemala?
Your response must be concise. 8.90e+05. In the year 1985, what is the difference between the Aid flow (current US$) of Burkina Faso and Aid flow (current US$) of Suriname?
Your answer should be compact. 2.10e+05. In the year 1985, what is the difference between the Aid flow (current US$) of Djibouti and Aid flow (current US$) of Guatemala?
Your answer should be very brief. -1.00e+05. In the year 1985, what is the difference between the Aid flow (current US$) in Djibouti and Aid flow (current US$) in Suriname?
Offer a very short reply. -7.80e+05. In the year 1985, what is the difference between the Aid flow (current US$) of Guatemala and Aid flow (current US$) of Suriname?
Provide a short and direct response. -6.80e+05. In the year 1986, what is the difference between the Aid flow (current US$) of Burkina Faso and Aid flow (current US$) of Djibouti?
Give a very brief answer. 2.06e+06. In the year 1986, what is the difference between the Aid flow (current US$) in Burkina Faso and Aid flow (current US$) in Guatemala?
Provide a short and direct response. 2.10e+06. In the year 1986, what is the difference between the Aid flow (current US$) in Burkina Faso and Aid flow (current US$) in Suriname?
Your answer should be very brief. 5.30e+05. In the year 1986, what is the difference between the Aid flow (current US$) of Djibouti and Aid flow (current US$) of Guatemala?
Offer a terse response. 4.00e+04. In the year 1986, what is the difference between the Aid flow (current US$) in Djibouti and Aid flow (current US$) in Suriname?
Offer a very short reply. -1.53e+06. In the year 1986, what is the difference between the Aid flow (current US$) of Guatemala and Aid flow (current US$) of Suriname?
Make the answer very short. -1.57e+06. In the year 1987, what is the difference between the Aid flow (current US$) in Burkina Faso and Aid flow (current US$) in Djibouti?
Give a very brief answer. 2.90e+06. In the year 1987, what is the difference between the Aid flow (current US$) in Burkina Faso and Aid flow (current US$) in Guatemala?
Provide a short and direct response. 2.65e+06. In the year 1987, what is the difference between the Aid flow (current US$) in Burkina Faso and Aid flow (current US$) in Suriname?
Your answer should be compact. 1.81e+06. In the year 1987, what is the difference between the Aid flow (current US$) in Djibouti and Aid flow (current US$) in Suriname?
Offer a terse response. -1.09e+06. In the year 1987, what is the difference between the Aid flow (current US$) in Guatemala and Aid flow (current US$) in Suriname?
Your response must be concise. -8.40e+05. In the year 1988, what is the difference between the Aid flow (current US$) in Burkina Faso and Aid flow (current US$) in Djibouti?
Offer a terse response. 1.76e+06. In the year 1988, what is the difference between the Aid flow (current US$) in Burkina Faso and Aid flow (current US$) in Guatemala?
Keep it short and to the point. 1.09e+06. In the year 1988, what is the difference between the Aid flow (current US$) in Djibouti and Aid flow (current US$) in Guatemala?
Provide a succinct answer. -6.70e+05. In the year 1988, what is the difference between the Aid flow (current US$) in Djibouti and Aid flow (current US$) in Suriname?
Offer a terse response. -1.28e+06. In the year 1988, what is the difference between the Aid flow (current US$) in Guatemala and Aid flow (current US$) in Suriname?
Make the answer very short. -6.10e+05. In the year 1989, what is the difference between the Aid flow (current US$) of Burkina Faso and Aid flow (current US$) of Djibouti?
Make the answer very short. 1.19e+06. In the year 1989, what is the difference between the Aid flow (current US$) of Burkina Faso and Aid flow (current US$) of Guatemala?
Keep it short and to the point. -4.60e+05. In the year 1989, what is the difference between the Aid flow (current US$) of Djibouti and Aid flow (current US$) of Guatemala?
Provide a short and direct response. -1.65e+06. In the year 1989, what is the difference between the Aid flow (current US$) of Djibouti and Aid flow (current US$) of Suriname?
Make the answer very short. -1.23e+06. What is the ratio of the Aid flow (current US$) in Burkina Faso in 1978 to that in 1980?
Your answer should be very brief. 0.64. What is the ratio of the Aid flow (current US$) in Guatemala in 1978 to that in 1980?
Your response must be concise. 0.58. What is the ratio of the Aid flow (current US$) of Suriname in 1978 to that in 1980?
Provide a succinct answer. 0.08. What is the ratio of the Aid flow (current US$) of Burkina Faso in 1978 to that in 1981?
Keep it short and to the point. 1.18. What is the ratio of the Aid flow (current US$) in Djibouti in 1978 to that in 1981?
Your answer should be compact. 1.67. What is the ratio of the Aid flow (current US$) of Guatemala in 1978 to that in 1981?
Provide a succinct answer. 1.07. What is the ratio of the Aid flow (current US$) in Suriname in 1978 to that in 1981?
Provide a short and direct response. 0.08. What is the ratio of the Aid flow (current US$) of Burkina Faso in 1978 to that in 1985?
Your response must be concise. 0.97. What is the ratio of the Aid flow (current US$) of Guatemala in 1978 to that in 1985?
Your response must be concise. 1.82. What is the ratio of the Aid flow (current US$) in Suriname in 1978 to that in 1985?
Ensure brevity in your answer.  0.05. What is the ratio of the Aid flow (current US$) in Burkina Faso in 1978 to that in 1986?
Your response must be concise. 0.45. What is the ratio of the Aid flow (current US$) of Djibouti in 1978 to that in 1986?
Your answer should be very brief. 0.22. What is the ratio of the Aid flow (current US$) in Guatemala in 1978 to that in 1986?
Ensure brevity in your answer.  1.63. What is the ratio of the Aid flow (current US$) in Suriname in 1978 to that in 1986?
Offer a very short reply. 0.02. What is the ratio of the Aid flow (current US$) of Burkina Faso in 1978 to that in 1987?
Your answer should be compact. 0.35. What is the ratio of the Aid flow (current US$) of Djibouti in 1978 to that in 1987?
Provide a short and direct response. 0.62. What is the ratio of the Aid flow (current US$) of Guatemala in 1978 to that in 1987?
Make the answer very short. 0.94. What is the ratio of the Aid flow (current US$) of Suriname in 1978 to that in 1987?
Provide a succinct answer. 0.03. What is the ratio of the Aid flow (current US$) in Burkina Faso in 1978 to that in 1988?
Keep it short and to the point. 0.56. What is the ratio of the Aid flow (current US$) of Guatemala in 1978 to that in 1988?
Offer a terse response. 0.42. What is the ratio of the Aid flow (current US$) in Suriname in 1978 to that in 1988?
Your answer should be very brief. 0.03. What is the ratio of the Aid flow (current US$) in Burkina Faso in 1978 to that in 1989?
Your answer should be very brief. 0.85. What is the ratio of the Aid flow (current US$) in Djibouti in 1978 to that in 1989?
Your answer should be compact. 2.5. What is the ratio of the Aid flow (current US$) of Guatemala in 1978 to that in 1989?
Your answer should be very brief. 0.19. What is the ratio of the Aid flow (current US$) of Suriname in 1978 to that in 1989?
Keep it short and to the point. 0.03. What is the ratio of the Aid flow (current US$) in Burkina Faso in 1980 to that in 1981?
Provide a short and direct response. 1.85. What is the ratio of the Aid flow (current US$) of Djibouti in 1980 to that in 1981?
Make the answer very short. 1.67. What is the ratio of the Aid flow (current US$) of Guatemala in 1980 to that in 1981?
Provide a short and direct response. 1.83. What is the ratio of the Aid flow (current US$) in Suriname in 1980 to that in 1981?
Your answer should be compact. 0.96. What is the ratio of the Aid flow (current US$) of Burkina Faso in 1980 to that in 1985?
Your response must be concise. 1.52. What is the ratio of the Aid flow (current US$) of Guatemala in 1980 to that in 1985?
Your answer should be compact. 3.12. What is the ratio of the Aid flow (current US$) in Suriname in 1980 to that in 1985?
Make the answer very short. 0.59. What is the ratio of the Aid flow (current US$) of Burkina Faso in 1980 to that in 1986?
Ensure brevity in your answer.  0.7. What is the ratio of the Aid flow (current US$) in Djibouti in 1980 to that in 1986?
Provide a succinct answer. 0.22. What is the ratio of the Aid flow (current US$) in Guatemala in 1980 to that in 1986?
Offer a very short reply. 2.79. What is the ratio of the Aid flow (current US$) in Suriname in 1980 to that in 1986?
Offer a terse response. 0.28. What is the ratio of the Aid flow (current US$) in Burkina Faso in 1980 to that in 1987?
Provide a succinct answer. 0.54. What is the ratio of the Aid flow (current US$) of Djibouti in 1980 to that in 1987?
Provide a short and direct response. 0.62. What is the ratio of the Aid flow (current US$) of Guatemala in 1980 to that in 1987?
Your response must be concise. 1.61. What is the ratio of the Aid flow (current US$) in Suriname in 1980 to that in 1987?
Provide a succinct answer. 0.43. What is the ratio of the Aid flow (current US$) of Burkina Faso in 1980 to that in 1988?
Ensure brevity in your answer.  0.88. What is the ratio of the Aid flow (current US$) in Djibouti in 1980 to that in 1988?
Your response must be concise. 0.71. What is the ratio of the Aid flow (current US$) of Guatemala in 1980 to that in 1988?
Give a very brief answer. 0.72. What is the ratio of the Aid flow (current US$) of Suriname in 1980 to that in 1988?
Give a very brief answer. 0.37. What is the ratio of the Aid flow (current US$) of Burkina Faso in 1980 to that in 1989?
Give a very brief answer. 1.33. What is the ratio of the Aid flow (current US$) of Guatemala in 1980 to that in 1989?
Make the answer very short. 0.32. What is the ratio of the Aid flow (current US$) in Suriname in 1980 to that in 1989?
Your answer should be compact. 0.4. What is the ratio of the Aid flow (current US$) of Burkina Faso in 1981 to that in 1985?
Your answer should be very brief. 0.82. What is the ratio of the Aid flow (current US$) in Djibouti in 1981 to that in 1985?
Provide a short and direct response. 0.43. What is the ratio of the Aid flow (current US$) of Guatemala in 1981 to that in 1985?
Provide a succinct answer. 1.71. What is the ratio of the Aid flow (current US$) in Suriname in 1981 to that in 1985?
Give a very brief answer. 0.61. What is the ratio of the Aid flow (current US$) of Burkina Faso in 1981 to that in 1986?
Provide a succinct answer. 0.38. What is the ratio of the Aid flow (current US$) of Djibouti in 1981 to that in 1986?
Offer a terse response. 0.13. What is the ratio of the Aid flow (current US$) in Guatemala in 1981 to that in 1986?
Offer a terse response. 1.53. What is the ratio of the Aid flow (current US$) of Suriname in 1981 to that in 1986?
Your answer should be compact. 0.3. What is the ratio of the Aid flow (current US$) of Burkina Faso in 1981 to that in 1987?
Offer a terse response. 0.29. What is the ratio of the Aid flow (current US$) in Djibouti in 1981 to that in 1987?
Make the answer very short. 0.38. What is the ratio of the Aid flow (current US$) in Guatemala in 1981 to that in 1987?
Provide a short and direct response. 0.88. What is the ratio of the Aid flow (current US$) of Suriname in 1981 to that in 1987?
Give a very brief answer. 0.44. What is the ratio of the Aid flow (current US$) in Burkina Faso in 1981 to that in 1988?
Make the answer very short. 0.48. What is the ratio of the Aid flow (current US$) in Djibouti in 1981 to that in 1988?
Your answer should be very brief. 0.43. What is the ratio of the Aid flow (current US$) of Guatemala in 1981 to that in 1988?
Make the answer very short. 0.39. What is the ratio of the Aid flow (current US$) of Suriname in 1981 to that in 1988?
Provide a succinct answer. 0.39. What is the ratio of the Aid flow (current US$) of Burkina Faso in 1981 to that in 1989?
Make the answer very short. 0.72. What is the ratio of the Aid flow (current US$) in Guatemala in 1981 to that in 1989?
Provide a succinct answer. 0.17. What is the ratio of the Aid flow (current US$) of Suriname in 1981 to that in 1989?
Ensure brevity in your answer.  0.42. What is the ratio of the Aid flow (current US$) of Burkina Faso in 1985 to that in 1986?
Provide a short and direct response. 0.46. What is the ratio of the Aid flow (current US$) in Djibouti in 1985 to that in 1986?
Offer a very short reply. 0.3. What is the ratio of the Aid flow (current US$) in Guatemala in 1985 to that in 1986?
Make the answer very short. 0.89. What is the ratio of the Aid flow (current US$) in Suriname in 1985 to that in 1986?
Give a very brief answer. 0.48. What is the ratio of the Aid flow (current US$) in Burkina Faso in 1985 to that in 1987?
Give a very brief answer. 0.36. What is the ratio of the Aid flow (current US$) of Djibouti in 1985 to that in 1987?
Keep it short and to the point. 0.88. What is the ratio of the Aid flow (current US$) of Guatemala in 1985 to that in 1987?
Your response must be concise. 0.52. What is the ratio of the Aid flow (current US$) in Suriname in 1985 to that in 1987?
Your response must be concise. 0.73. What is the ratio of the Aid flow (current US$) of Burkina Faso in 1985 to that in 1988?
Keep it short and to the point. 0.58. What is the ratio of the Aid flow (current US$) of Djibouti in 1985 to that in 1988?
Keep it short and to the point. 1. What is the ratio of the Aid flow (current US$) in Guatemala in 1985 to that in 1988?
Keep it short and to the point. 0.23. What is the ratio of the Aid flow (current US$) of Suriname in 1985 to that in 1988?
Give a very brief answer. 0.63. What is the ratio of the Aid flow (current US$) of Burkina Faso in 1985 to that in 1989?
Offer a very short reply. 0.88. What is the ratio of the Aid flow (current US$) of Djibouti in 1985 to that in 1989?
Your response must be concise. 3.5. What is the ratio of the Aid flow (current US$) in Guatemala in 1985 to that in 1989?
Offer a terse response. 0.1. What is the ratio of the Aid flow (current US$) of Suriname in 1985 to that in 1989?
Keep it short and to the point. 0.68. What is the ratio of the Aid flow (current US$) of Burkina Faso in 1986 to that in 1987?
Keep it short and to the point. 0.77. What is the ratio of the Aid flow (current US$) of Djibouti in 1986 to that in 1987?
Your answer should be compact. 2.88. What is the ratio of the Aid flow (current US$) in Guatemala in 1986 to that in 1987?
Your response must be concise. 0.58. What is the ratio of the Aid flow (current US$) of Suriname in 1986 to that in 1987?
Your answer should be very brief. 1.5. What is the ratio of the Aid flow (current US$) of Burkina Faso in 1986 to that in 1988?
Ensure brevity in your answer.  1.25. What is the ratio of the Aid flow (current US$) of Djibouti in 1986 to that in 1988?
Keep it short and to the point. 3.29. What is the ratio of the Aid flow (current US$) of Guatemala in 1986 to that in 1988?
Keep it short and to the point. 0.26. What is the ratio of the Aid flow (current US$) in Suriname in 1986 to that in 1988?
Provide a succinct answer. 1.3. What is the ratio of the Aid flow (current US$) of Burkina Faso in 1986 to that in 1989?
Provide a short and direct response. 1.89. What is the ratio of the Aid flow (current US$) of Djibouti in 1986 to that in 1989?
Your answer should be compact. 11.5. What is the ratio of the Aid flow (current US$) of Guatemala in 1986 to that in 1989?
Your answer should be compact. 0.11. What is the ratio of the Aid flow (current US$) of Suriname in 1986 to that in 1989?
Your answer should be compact. 1.41. What is the ratio of the Aid flow (current US$) in Burkina Faso in 1987 to that in 1988?
Offer a very short reply. 1.63. What is the ratio of the Aid flow (current US$) in Djibouti in 1987 to that in 1988?
Keep it short and to the point. 1.14. What is the ratio of the Aid flow (current US$) of Guatemala in 1987 to that in 1988?
Keep it short and to the point. 0.45. What is the ratio of the Aid flow (current US$) in Suriname in 1987 to that in 1988?
Make the answer very short. 0.87. What is the ratio of the Aid flow (current US$) in Burkina Faso in 1987 to that in 1989?
Your answer should be very brief. 2.46. What is the ratio of the Aid flow (current US$) in Djibouti in 1987 to that in 1989?
Keep it short and to the point. 4. What is the ratio of the Aid flow (current US$) in Guatemala in 1987 to that in 1989?
Offer a terse response. 0.2. What is the ratio of the Aid flow (current US$) of Suriname in 1987 to that in 1989?
Provide a short and direct response. 0.94. What is the ratio of the Aid flow (current US$) of Burkina Faso in 1988 to that in 1989?
Offer a very short reply. 1.51. What is the ratio of the Aid flow (current US$) in Djibouti in 1988 to that in 1989?
Provide a short and direct response. 3.5. What is the ratio of the Aid flow (current US$) in Guatemala in 1988 to that in 1989?
Make the answer very short. 0.44. What is the difference between the highest and the second highest Aid flow (current US$) of Burkina Faso?
Your response must be concise. 6.90e+05. What is the difference between the highest and the second highest Aid flow (current US$) in Guatemala?
Your answer should be very brief. 9.30e+05. What is the difference between the highest and the second highest Aid flow (current US$) in Suriname?
Your answer should be very brief. 4.10e+05. What is the difference between the highest and the lowest Aid flow (current US$) in Burkina Faso?
Make the answer very short. 2.11e+06. What is the difference between the highest and the lowest Aid flow (current US$) of Guatemala?
Offer a very short reply. 1.50e+06. What is the difference between the highest and the lowest Aid flow (current US$) in Suriname?
Ensure brevity in your answer.  1.72e+06. 